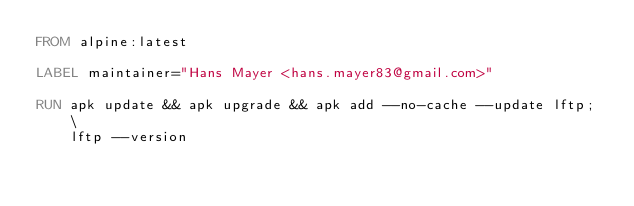Convert code to text. <code><loc_0><loc_0><loc_500><loc_500><_Dockerfile_>FROM alpine:latest

LABEL maintainer="Hans Mayer <hans.mayer83@gmail.com>"

RUN apk update && apk upgrade && apk add --no-cache --update lftp; \
    lftp --version
</code> 